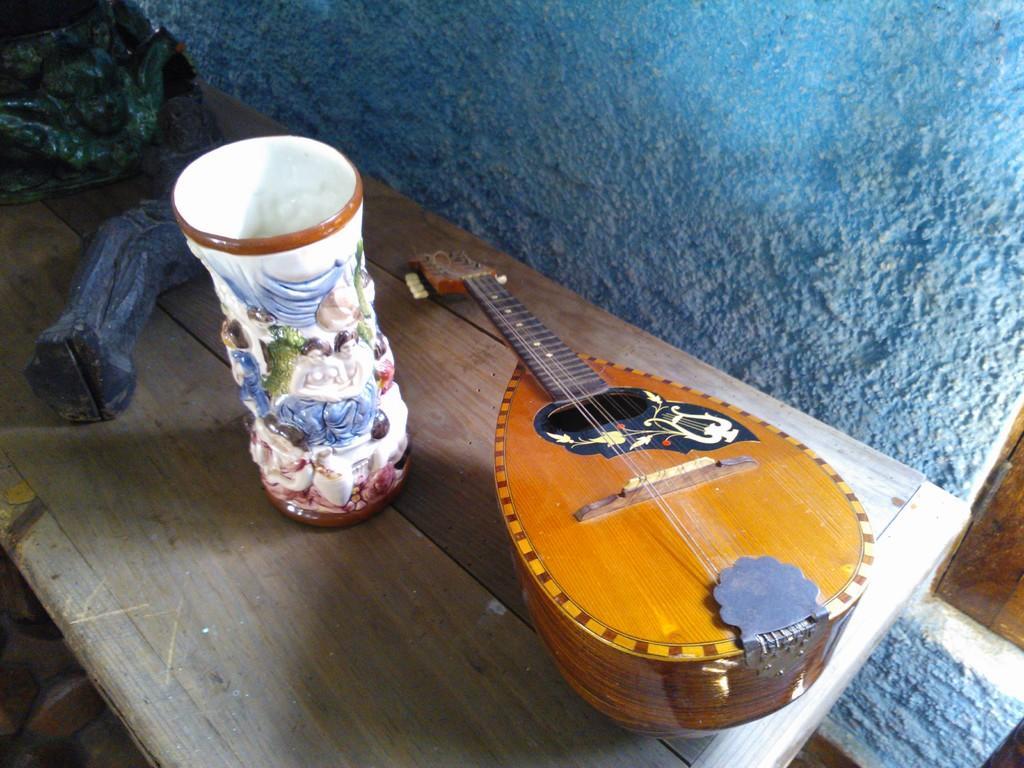Could you give a brief overview of what you see in this image? on the table there is a flower vase , a sitar. behind that there is a blue color wall. 